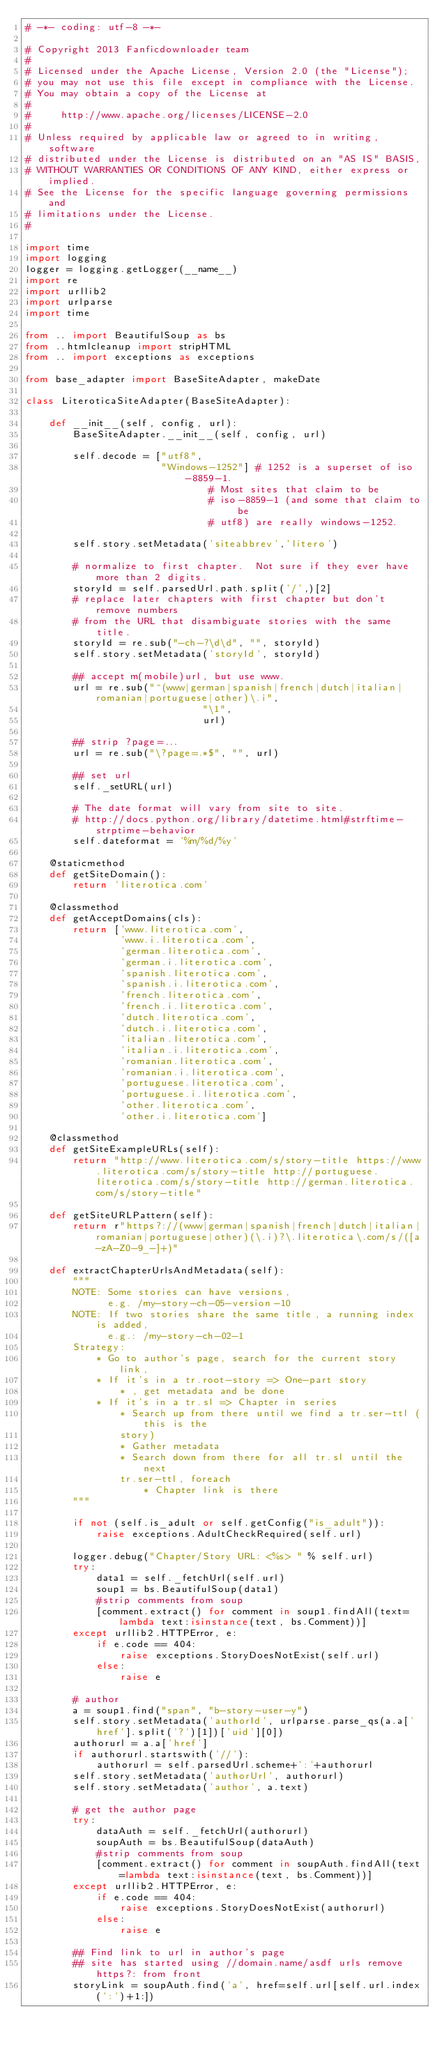Convert code to text. <code><loc_0><loc_0><loc_500><loc_500><_Python_># -*- coding: utf-8 -*-

# Copyright 2013 Fanficdownloader team
#
# Licensed under the Apache License, Version 2.0 (the "License");
# you may not use this file except in compliance with the License.
# You may obtain a copy of the License at
#
#     http://www.apache.org/licenses/LICENSE-2.0
#
# Unless required by applicable law or agreed to in writing, software
# distributed under the License is distributed on an "AS IS" BASIS,
# WITHOUT WARRANTIES OR CONDITIONS OF ANY KIND, either express or implied.
# See the License for the specific language governing permissions and
# limitations under the License.
#

import time
import logging
logger = logging.getLogger(__name__)
import re
import urllib2
import urlparse
import time

from .. import BeautifulSoup as bs
from ..htmlcleanup import stripHTML
from .. import exceptions as exceptions

from base_adapter import BaseSiteAdapter, makeDate

class LiteroticaSiteAdapter(BaseSiteAdapter):

    def __init__(self, config, url):
        BaseSiteAdapter.__init__(self, config, url)

        self.decode = ["utf8",
                       "Windows-1252"] # 1252 is a superset of iso-8859-1.
                               # Most sites that claim to be
                               # iso-8859-1 (and some that claim to be
                               # utf8) are really windows-1252.

        self.story.setMetadata('siteabbrev','litero')

        # normalize to first chapter.  Not sure if they ever have more than 2 digits.
        storyId = self.parsedUrl.path.split('/',)[2]
        # replace later chapters with first chapter but don't remove numbers
        # from the URL that disambiguate stories with the same title.
        storyId = re.sub("-ch-?\d\d", "", storyId)
        self.story.setMetadata('storyId', storyId)

        ## accept m(mobile)url, but use www.
        url = re.sub("^(www|german|spanish|french|dutch|italian|romanian|portuguese|other)\.i",
                              "\1",
                              url)

        ## strip ?page=...
        url = re.sub("\?page=.*$", "", url)

        ## set url
        self._setURL(url)

        # The date format will vary from site to site.
        # http://docs.python.org/library/datetime.html#strftime-strptime-behavior
        self.dateformat = '%m/%d/%y'

    @staticmethod
    def getSiteDomain():
        return 'literotica.com'

    @classmethod
    def getAcceptDomains(cls):
        return ['www.literotica.com',
                'www.i.literotica.com',
                'german.literotica.com',
                'german.i.literotica.com',
                'spanish.literotica.com',
                'spanish.i.literotica.com',
                'french.literotica.com',
                'french.i.literotica.com',
                'dutch.literotica.com',
                'dutch.i.literotica.com',
                'italian.literotica.com',
                'italian.i.literotica.com',
                'romanian.literotica.com',
                'romanian.i.literotica.com',
                'portuguese.literotica.com',
                'portuguese.i.literotica.com',
                'other.literotica.com',
                'other.i.literotica.com']

    @classmethod
    def getSiteExampleURLs(self):
        return "http://www.literotica.com/s/story-title https://www.literotica.com/s/story-title http://portuguese.literotica.com/s/story-title http://german.literotica.com/s/story-title"

    def getSiteURLPattern(self):
        return r"https?://(www|german|spanish|french|dutch|italian|romanian|portuguese|other)(\.i)?\.literotica\.com/s/([a-zA-Z0-9_-]+)"

    def extractChapterUrlsAndMetadata(self):
        """
        NOTE: Some stories can have versions, 
              e.g. /my-story-ch-05-version-10
        NOTE: If two stories share the same title, a running index is added,
              e.g.: /my-story-ch-02-1
        Strategy:
            * Go to author's page, search for the current story link,
            * If it's in a tr.root-story => One-part story
                * , get metadata and be done
            * If it's in a tr.sl => Chapter in series
                * Search up from there until we find a tr.ser-ttl (this is the
                story)
                * Gather metadata
                * Search down from there for all tr.sl until the next
                tr.ser-ttl, foreach
                    * Chapter link is there
        """

        if not (self.is_adult or self.getConfig("is_adult")):
            raise exceptions.AdultCheckRequired(self.url)

        logger.debug("Chapter/Story URL: <%s> " % self.url)
        try:
            data1 = self._fetchUrl(self.url)
            soup1 = bs.BeautifulSoup(data1)
            #strip comments from soup
            [comment.extract() for comment in soup1.findAll(text=lambda text:isinstance(text, bs.Comment))]
        except urllib2.HTTPError, e:
            if e.code == 404:
                raise exceptions.StoryDoesNotExist(self.url)
            else:
                raise e

        # author
        a = soup1.find("span", "b-story-user-y")
        self.story.setMetadata('authorId', urlparse.parse_qs(a.a['href'].split('?')[1])['uid'][0])
        authorurl = a.a['href']
        if authorurl.startswith('//'):
            authorurl = self.parsedUrl.scheme+':'+authorurl
        self.story.setMetadata('authorUrl', authorurl)
        self.story.setMetadata('author', a.text)

        # get the author page
        try:
            dataAuth = self._fetchUrl(authorurl)
            soupAuth = bs.BeautifulSoup(dataAuth)
            #strip comments from soup
            [comment.extract() for comment in soupAuth.findAll(text=lambda text:isinstance(text, bs.Comment))]
        except urllib2.HTTPError, e:
            if e.code == 404:
                raise exceptions.StoryDoesNotExist(authorurl)
            else:
                raise e

        ## Find link to url in author's page
        ## site has started using //domain.name/asdf urls remove https?: from front
        storyLink = soupAuth.find('a', href=self.url[self.url.index(':')+1:])
</code> 